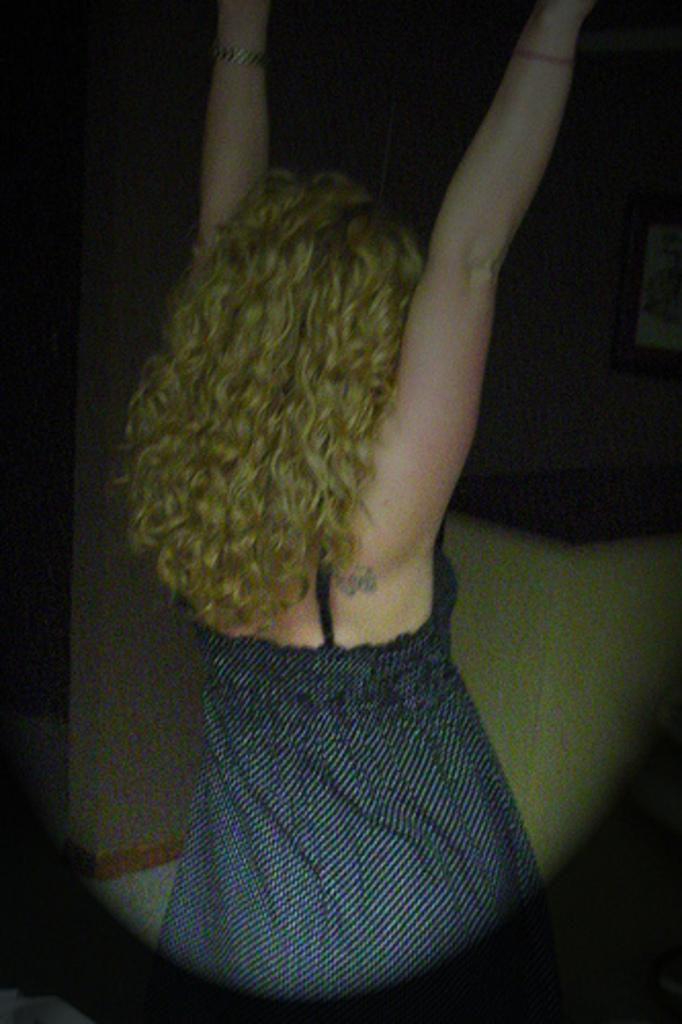What is the main subject in the image? There is a woman standing in the image. Can you describe anything on the wall in the image? There is a photo frame on the wall on the right side of the image. How many birds are sitting on the woman's shoulder in the image? There are no birds present in the image. What decision is the woman making in the image? The image does not provide any information about the woman making a decision. 